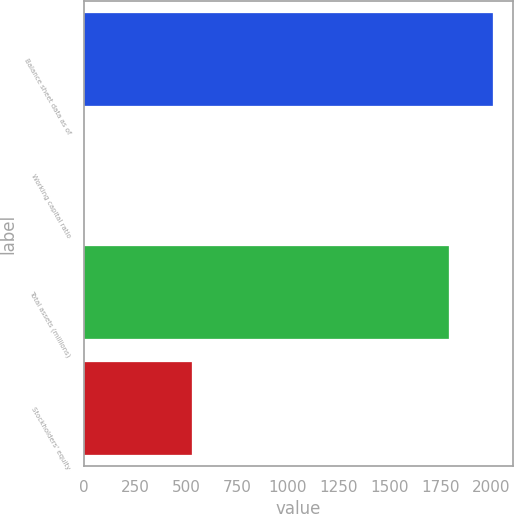<chart> <loc_0><loc_0><loc_500><loc_500><bar_chart><fcel>Balance sheet data as of<fcel>Working capital ratio<fcel>Total assets (millions)<fcel>Stockholders' equity<nl><fcel>2008<fcel>0.97<fcel>1793<fcel>529<nl></chart> 